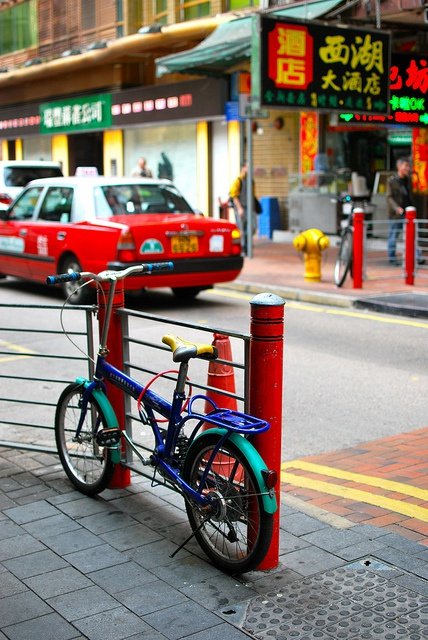Describe the objects in this image and their specific colors. I can see bicycle in gray, black, lightgray, and darkgray tones, car in gray, red, white, brown, and black tones, car in gray, black, white, lightblue, and teal tones, people in gray, black, brown, and maroon tones, and bicycle in gray, black, darkgray, and red tones in this image. 